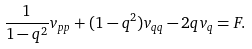<formula> <loc_0><loc_0><loc_500><loc_500>\frac { 1 } { 1 - q ^ { 2 } } v _ { p p } + ( 1 - q ^ { 2 } ) v _ { q q } - 2 q v _ { q } = F .</formula> 